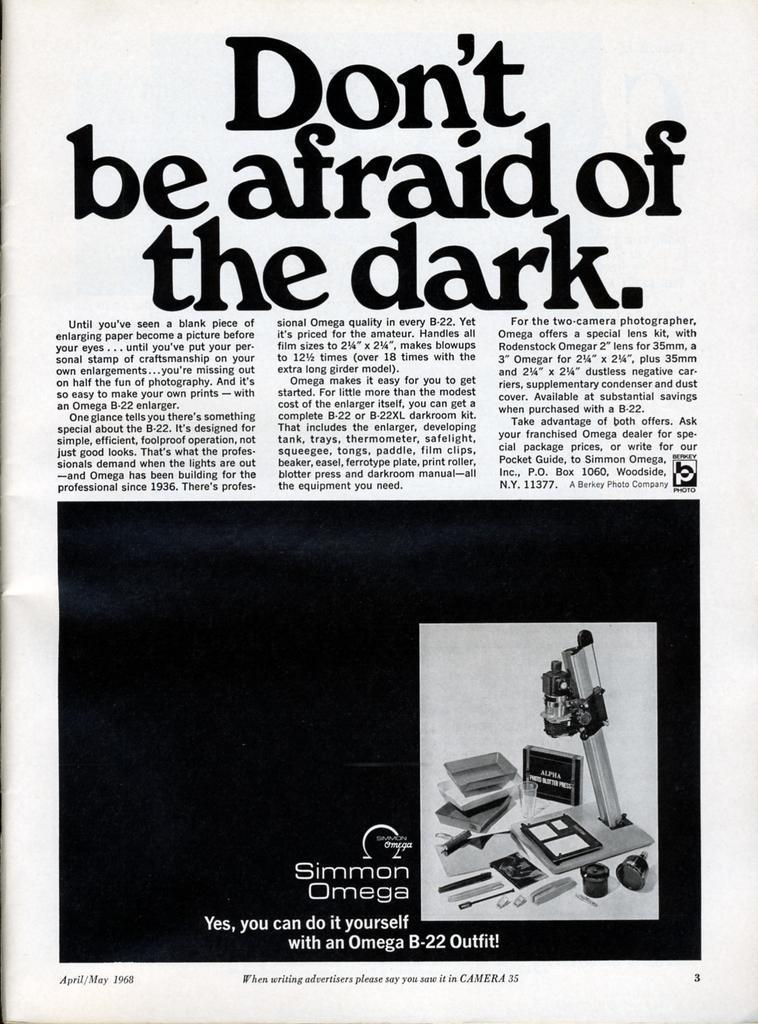Is this anadvert?
Keep it short and to the point. Yes. What does the page say to not be scared of?
Offer a very short reply. The dark. 